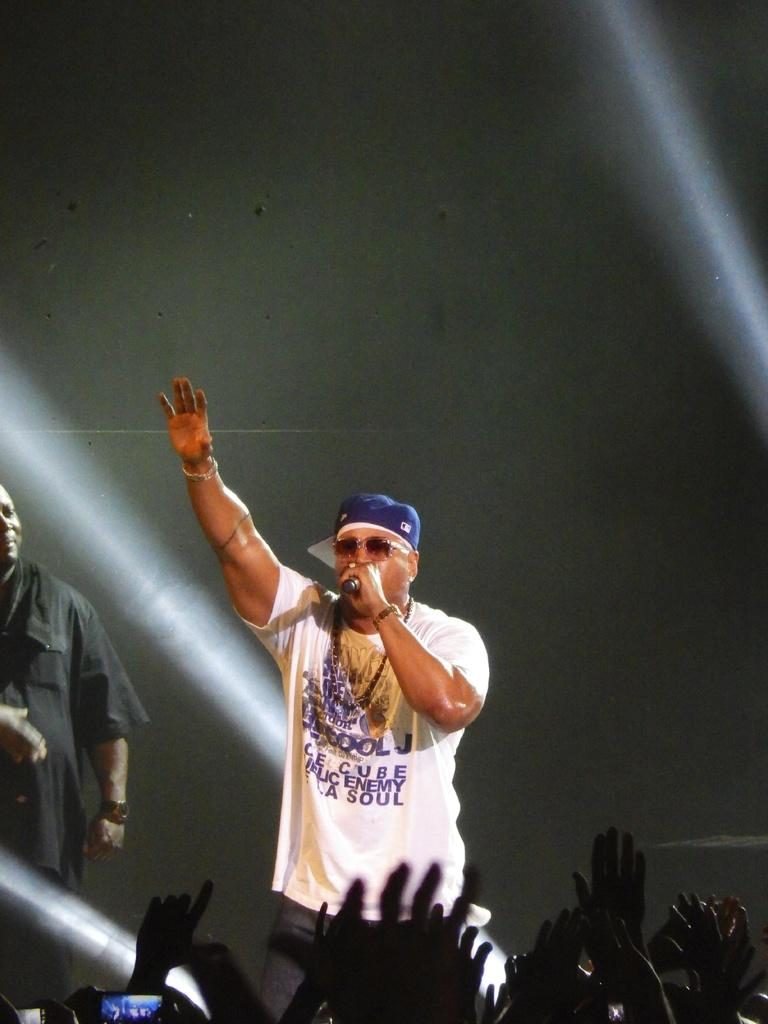<image>
Describe the image concisely. A man on a stage in a white shirt that reads ICE CUBE, PUBLIC ENEMY, DE LA SOUL 